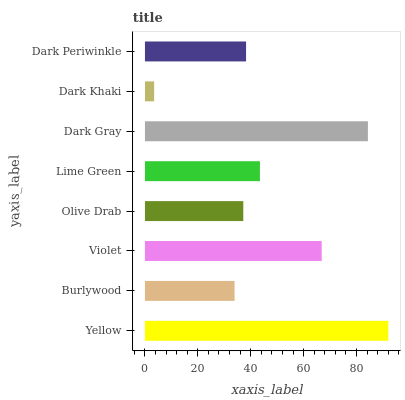Is Dark Khaki the minimum?
Answer yes or no. Yes. Is Yellow the maximum?
Answer yes or no. Yes. Is Burlywood the minimum?
Answer yes or no. No. Is Burlywood the maximum?
Answer yes or no. No. Is Yellow greater than Burlywood?
Answer yes or no. Yes. Is Burlywood less than Yellow?
Answer yes or no. Yes. Is Burlywood greater than Yellow?
Answer yes or no. No. Is Yellow less than Burlywood?
Answer yes or no. No. Is Lime Green the high median?
Answer yes or no. Yes. Is Dark Periwinkle the low median?
Answer yes or no. Yes. Is Olive Drab the high median?
Answer yes or no. No. Is Dark Gray the low median?
Answer yes or no. No. 